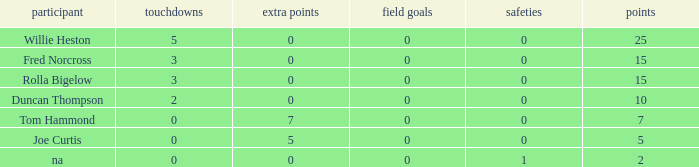Which Points is the lowest one that has Touchdowns smaller than 2, and an Extra points of 7, and a Field goals smaller than 0? None. 